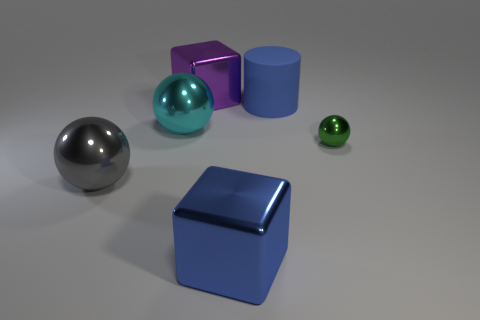Subtract all small green metallic balls. How many balls are left? 2 Add 3 large blue cylinders. How many objects exist? 9 Subtract all cylinders. How many objects are left? 5 Subtract all blue cubes. How many cubes are left? 1 Subtract 2 cubes. How many cubes are left? 0 Subtract all red cylinders. Subtract all cyan cubes. How many cylinders are left? 1 Subtract all big objects. Subtract all big gray rubber blocks. How many objects are left? 1 Add 1 tiny green things. How many tiny green things are left? 2 Add 3 small cyan cubes. How many small cyan cubes exist? 3 Subtract 0 brown blocks. How many objects are left? 6 